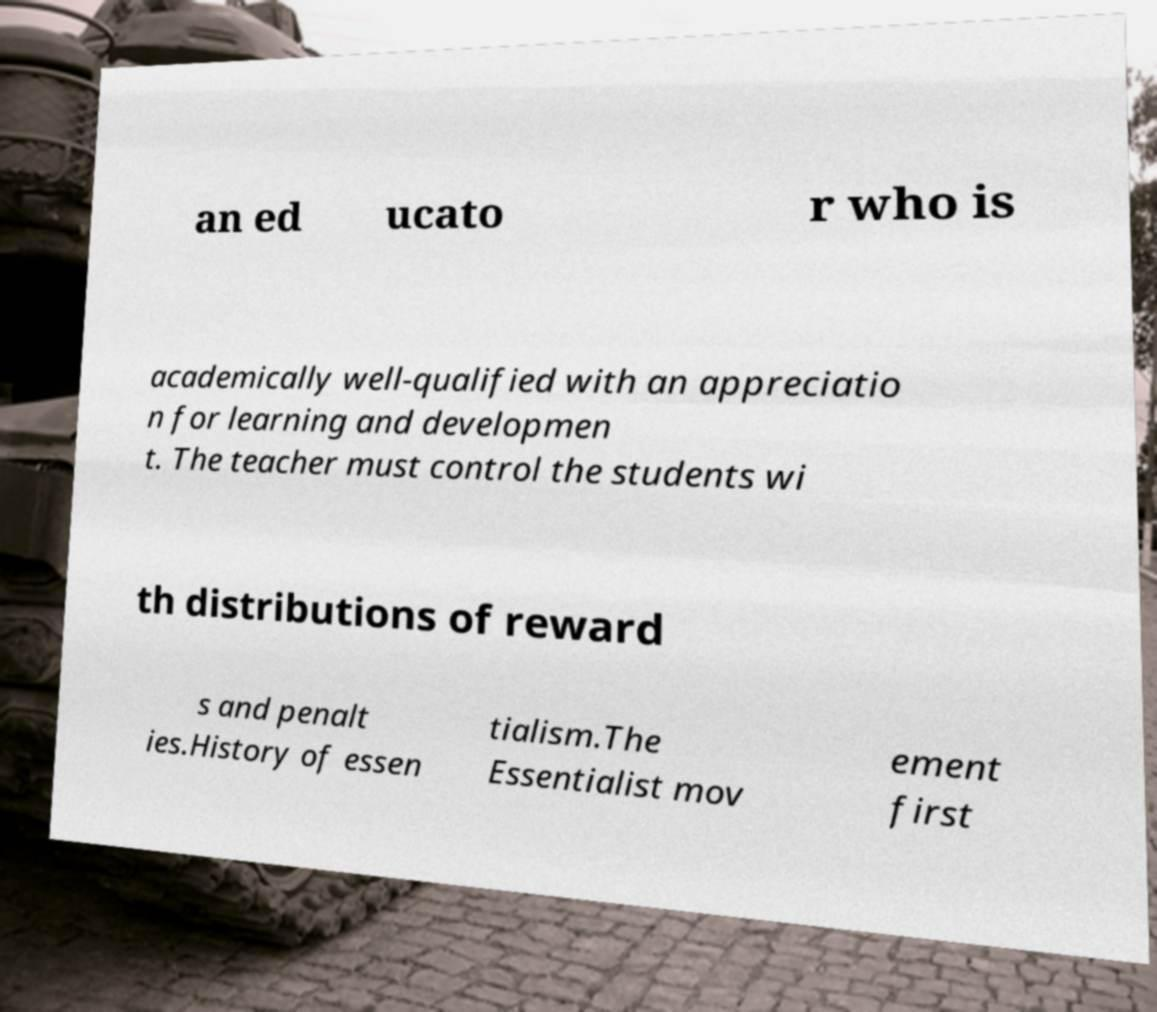What messages or text are displayed in this image? I need them in a readable, typed format. an ed ucato r who is academically well-qualified with an appreciatio n for learning and developmen t. The teacher must control the students wi th distributions of reward s and penalt ies.History of essen tialism.The Essentialist mov ement first 